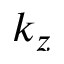<formula> <loc_0><loc_0><loc_500><loc_500>k _ { z }</formula> 